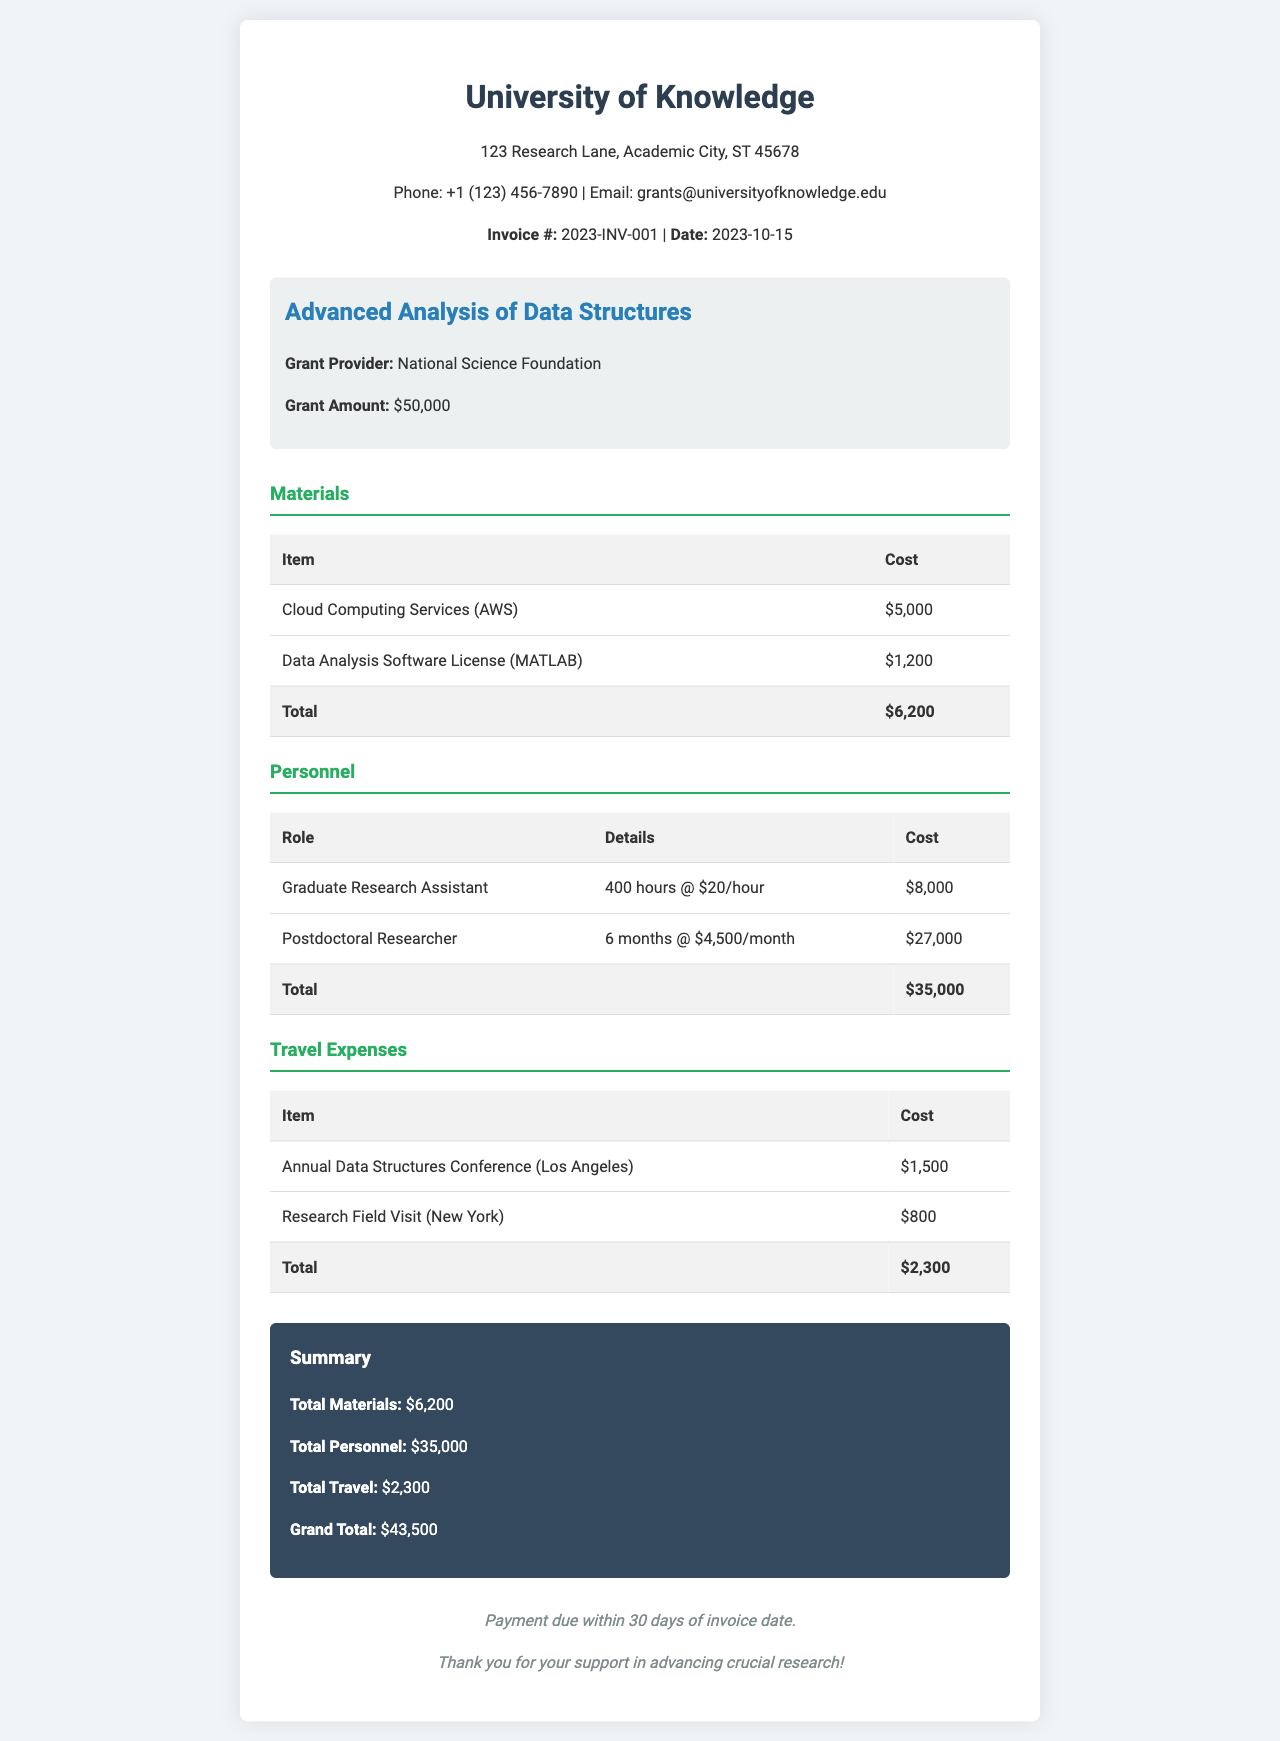what is the invoice number? The invoice number is stated in the document as 2023-INV-001.
Answer: 2023-INV-001 who is the grant provider? The grant provider mentioned in the document is the National Science Foundation.
Answer: National Science Foundation what is the total cost for materials? The total cost for materials is listed in the breakdown section, which totals to $6,200.
Answer: $6,200 how many hours did the Graduate Research Assistant work? The document specifies that the Graduate Research Assistant worked for 400 hours.
Answer: 400 hours what is the cost of travel expenses? The total travel expenses are summed up in the travel expenses section, which totals $2,300.
Answer: $2,300 what is the grand total of the invoice? The grand total of the invoice is summarized at the end of the document, amounting to $43,500.
Answer: $43,500 how long did the Postdoctoral Researcher work? The document states that the Postdoctoral Researcher worked for 6 months.
Answer: 6 months what was the location of the Annual Data Structures Conference? The location for the conference is specified as Los Angeles in the travel expenses section.
Answer: Los Angeles when is the payment due? The document states that payment is due within 30 days of the invoice date.
Answer: 30 days 